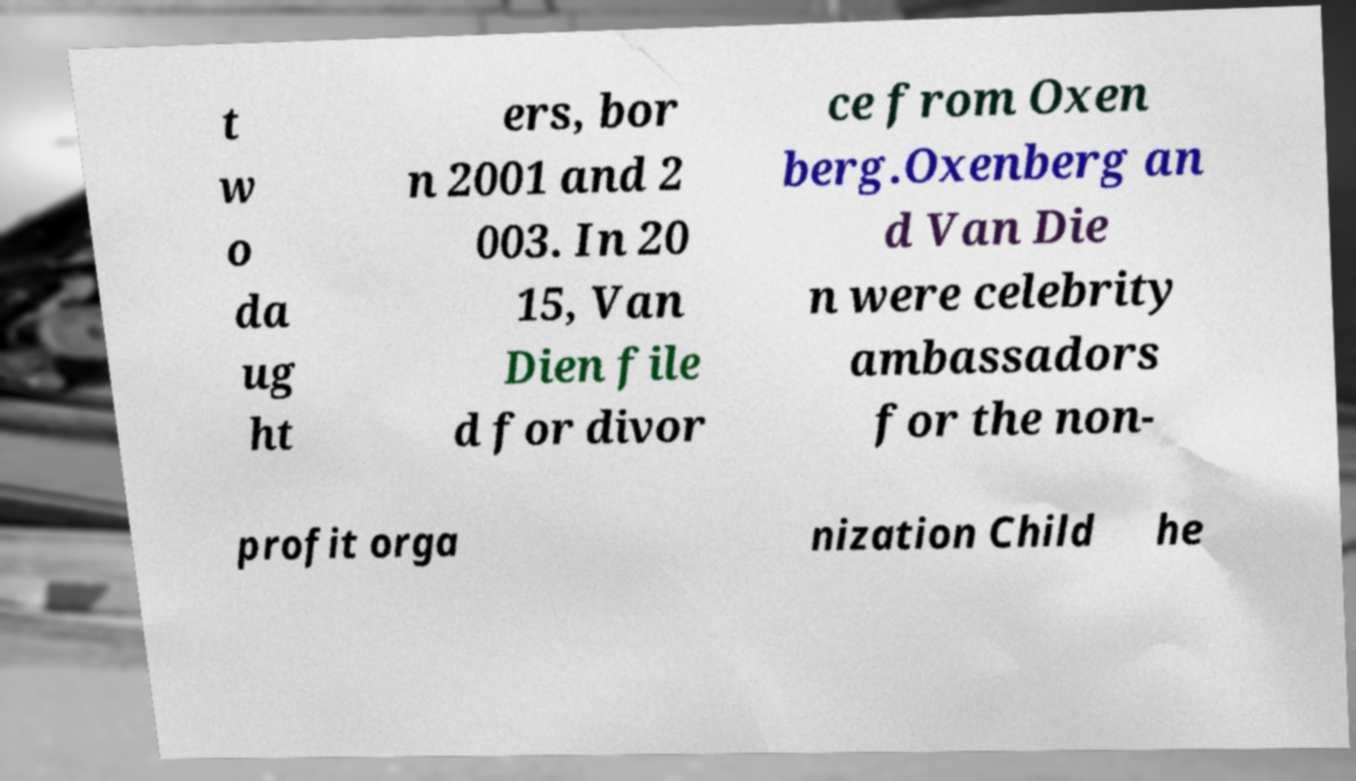I need the written content from this picture converted into text. Can you do that? t w o da ug ht ers, bor n 2001 and 2 003. In 20 15, Van Dien file d for divor ce from Oxen berg.Oxenberg an d Van Die n were celebrity ambassadors for the non- profit orga nization Child he 